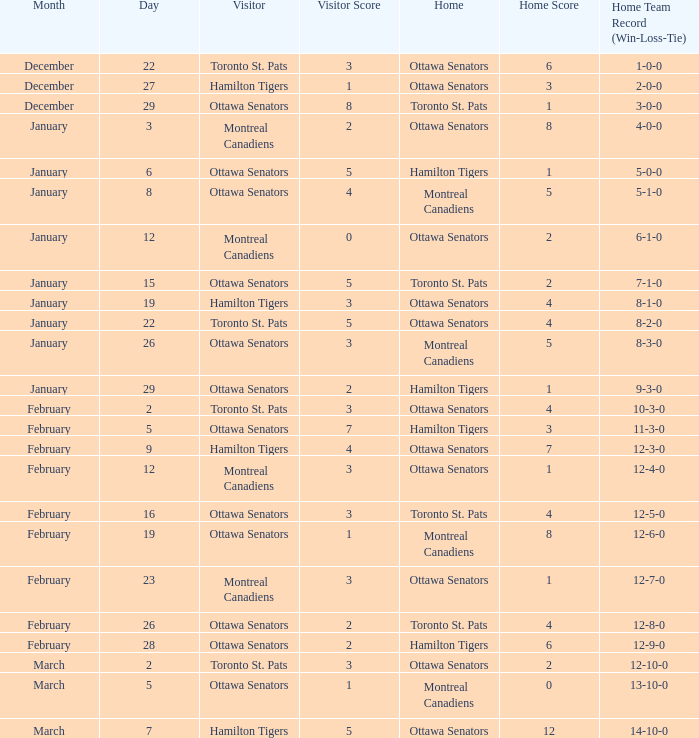Who was the home team when the vistor team was the Montreal Canadiens on February 12? Ottawa Senators. 